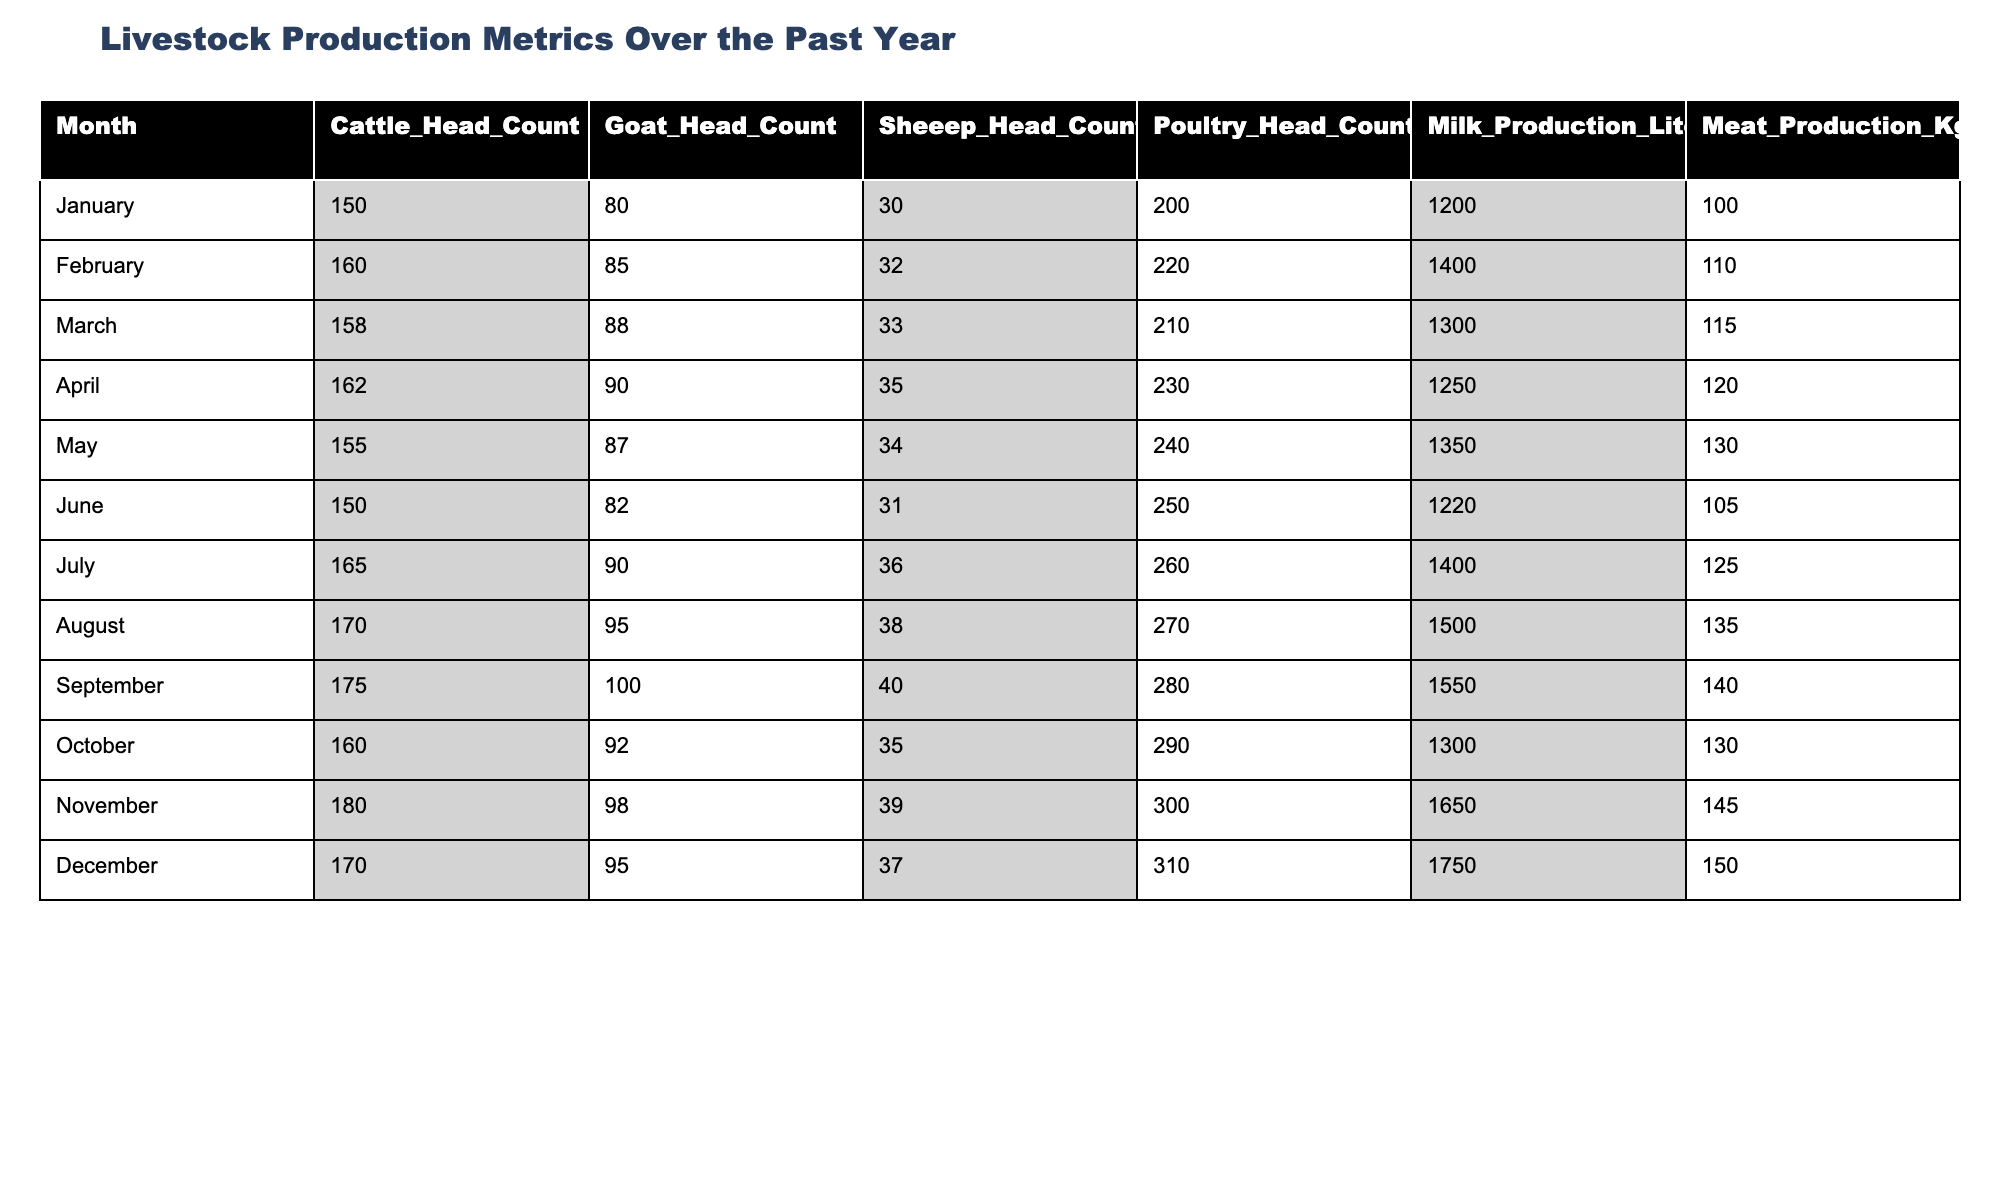What is the highest cattle head count recorded in the year? By reviewing the table, we find the highest number of cattle head count is in November, which is 180.
Answer: 180 Which month had the lowest poultry head count? Looking at the table, June has the lowest poultry head count, which is 250.
Answer: 250 How much milk was produced in total over the year? We can find the total milk production by adding all the monthly values: 1200 + 1400 + 1300 + 1250 + 1350 + 1220 + 1400 + 1500 + 1550 + 1300 + 1650 + 1750 = 16250 liters.
Answer: 16250 liters Which month had the highest meat production? By examining the table, we see that December had the highest meat production at 150 kg.
Answer: 150 kg What is the average number of goats kept over the year? To find the average for goats, we first sum their head counts for the year: 80 + 85 + 88 + 90 + 87 + 82 + 90 + 95 + 100 + 92 + 98 + 95 = 1030. Then, we divide by the number of months (12): 1030 / 12 ≈ 85.83.
Answer: 85.83 Did the number of sheep head counts increase or decrease from January to December? From the table, we see that sheep head counts increased from 30 in January to 37 in December, indicating an increase.
Answer: Yes How much more milk was produced in August compared to June? The milk production in August is 1500 liters and in June it is 1220 liters. Thus, the difference is 1500 - 1220 = 280 liters.
Answer: 280 liters Which livestock produced a greater total weight in meat, cattle or sheep, over the year? We sum the total meat production for cattle (the values: 100 + 110 + 115 + 120 + 130 + 105 + 125 + 135 + 140 + 130 + 145 + 150 = 1555 kg) and for sheep (the values: 30 + 32 + 33 + 35 + 34 + 31 + 36 + 38 + 40 + 35 + 39 + 37 = 438 kg). Cattle produced significantly more at 1555 kg than sheep's 438 kg.
Answer: Cattle What was the percentage increase in poultry head count from January to December? The poultry head count rose from 200 in January to 310 in December. The increase is 310 - 200 = 110. The percentage increase is (110 / 200) * 100 = 55%.
Answer: 55% In how many months did the milk production exceed 1400 liters? By checking the table, milk production exceeded 1400 liters in 4 months: February, May, August, November, and December.
Answer: 5 months 